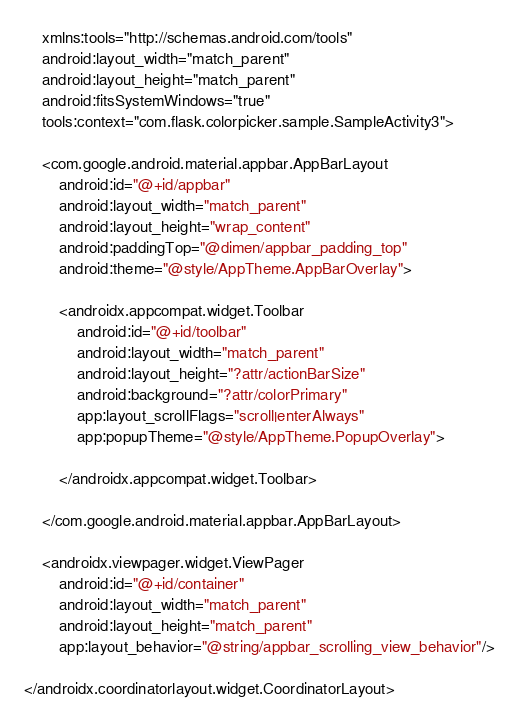Convert code to text. <code><loc_0><loc_0><loc_500><loc_500><_XML_>	xmlns:tools="http://schemas.android.com/tools"
	android:layout_width="match_parent"
	android:layout_height="match_parent"
	android:fitsSystemWindows="true"
	tools:context="com.flask.colorpicker.sample.SampleActivity3">

	<com.google.android.material.appbar.AppBarLayout
		android:id="@+id/appbar"
		android:layout_width="match_parent"
		android:layout_height="wrap_content"
		android:paddingTop="@dimen/appbar_padding_top"
		android:theme="@style/AppTheme.AppBarOverlay">

		<androidx.appcompat.widget.Toolbar
			android:id="@+id/toolbar"
			android:layout_width="match_parent"
			android:layout_height="?attr/actionBarSize"
			android:background="?attr/colorPrimary"
			app:layout_scrollFlags="scroll|enterAlways"
			app:popupTheme="@style/AppTheme.PopupOverlay">

		</androidx.appcompat.widget.Toolbar>

	</com.google.android.material.appbar.AppBarLayout>

	<androidx.viewpager.widget.ViewPager
		android:id="@+id/container"
		android:layout_width="match_parent"
		android:layout_height="match_parent"
		app:layout_behavior="@string/appbar_scrolling_view_behavior"/>

</androidx.coordinatorlayout.widget.CoordinatorLayout>
</code> 